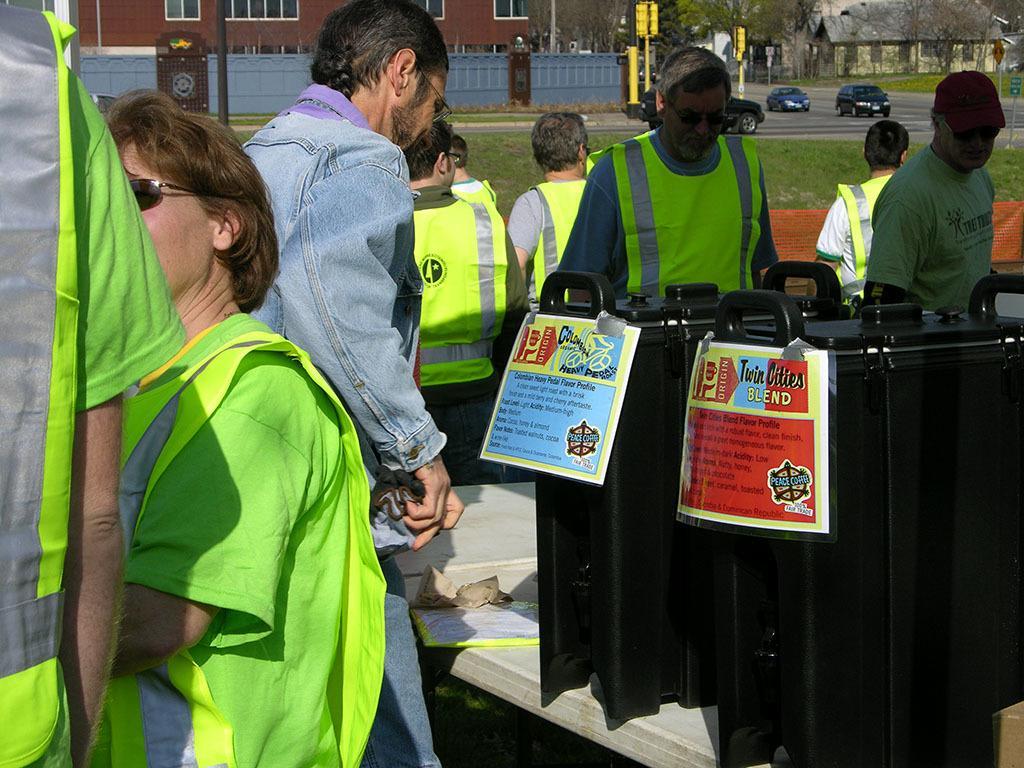Can you describe this image briefly? In this image there is a table in the middle on which there are two black boxes. Around the table there are few people standing on the floor who is wearing the green colour jacket. In the background there is a road on which there are three cars. Beside the road there are traffic signal lights. In the background there are buildings with the windows. On the ground there is grass. 